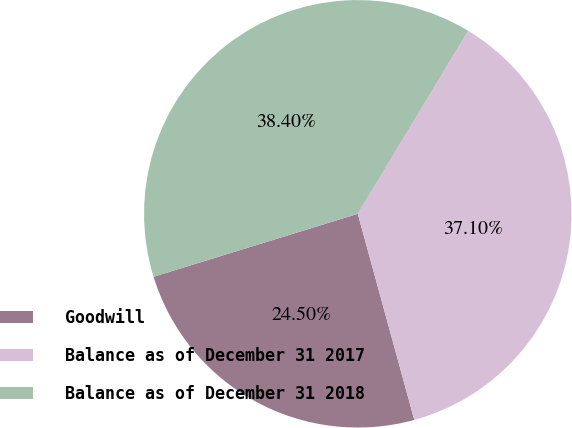<chart> <loc_0><loc_0><loc_500><loc_500><pie_chart><fcel>Goodwill<fcel>Balance as of December 31 2017<fcel>Balance as of December 31 2018<nl><fcel>24.5%<fcel>37.1%<fcel>38.4%<nl></chart> 